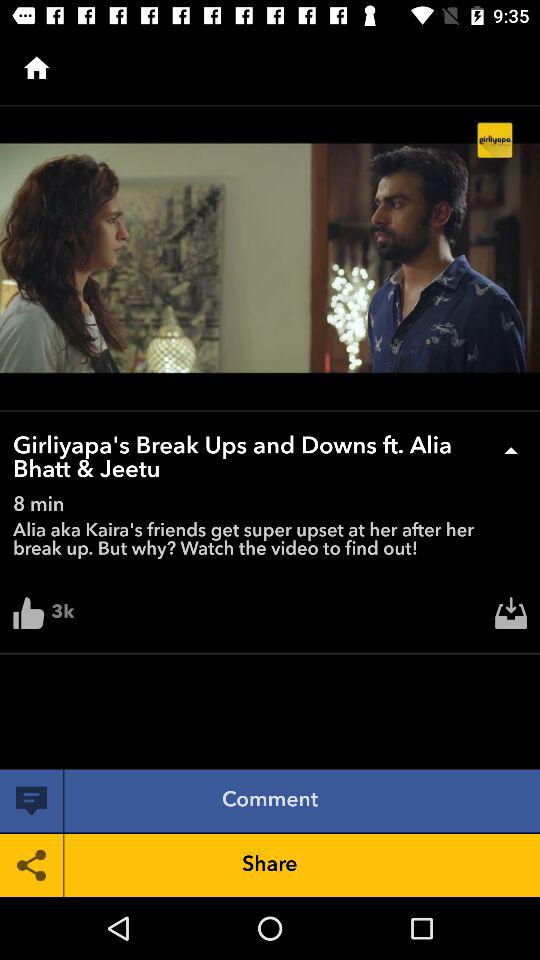How many thumbs up does the video have?
Answer the question using a single word or phrase. 3k 